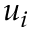Convert formula to latex. <formula><loc_0><loc_0><loc_500><loc_500>u _ { i }</formula> 